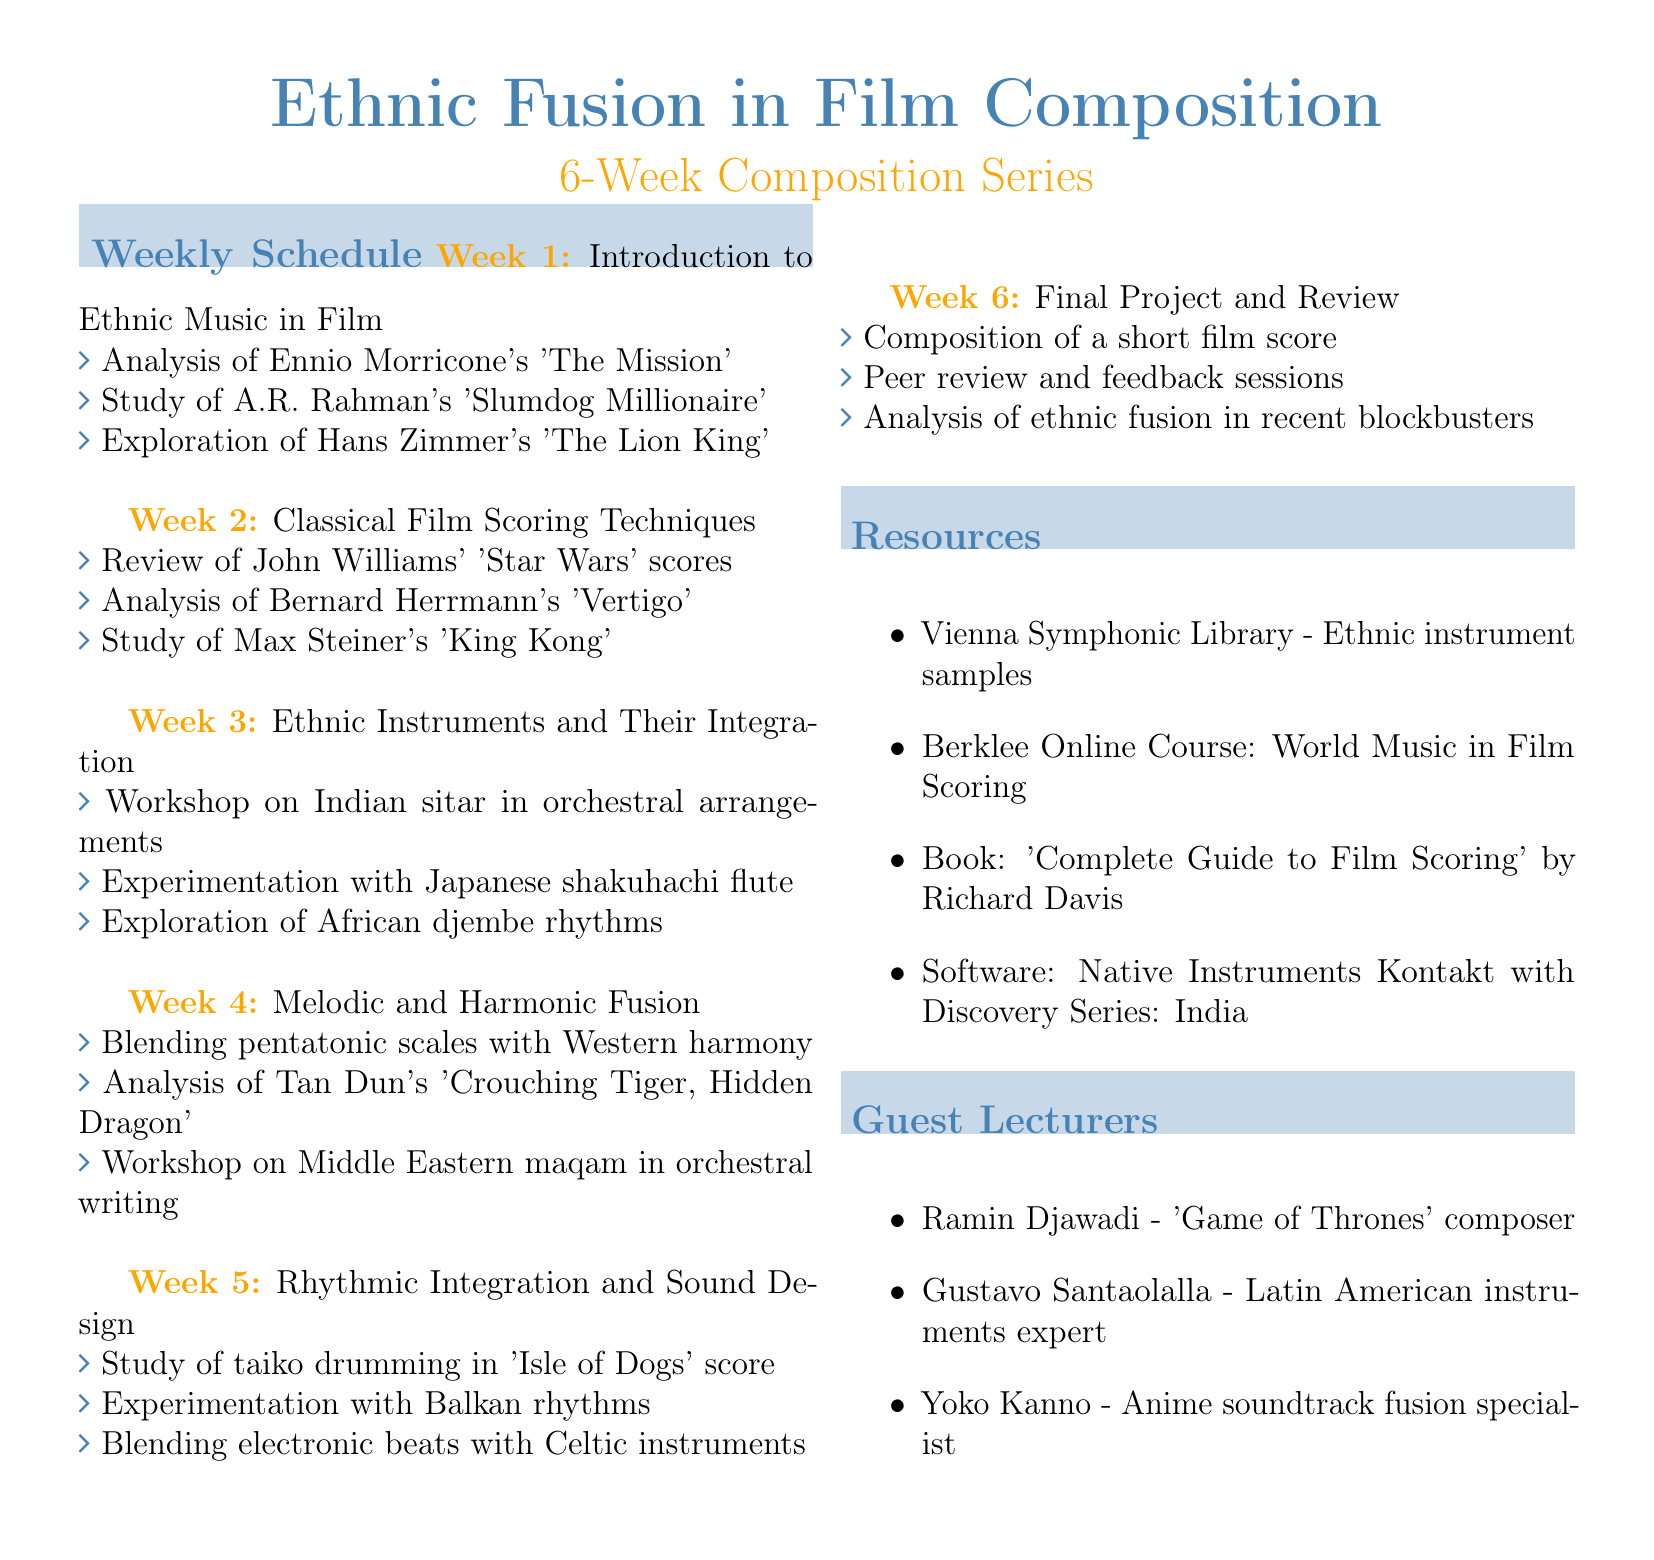What is the title of the session series? The title is the first line of the document.
Answer: Ethnic Fusion in Film Composition How long is the composition series? The duration is specified in the introduction section of the document.
Answer: 6 weeks Which week focuses on ethnic instruments? The week is identified in the Weekly Schedule section, under the third weekly topic.
Answer: Week 3 Who is a guest lecturer known for 'Game of Thrones'? The guest lecturer section lists several names, and this one is included among them.
Answer: Ramin Djawadi What type of activity occurs in week 4? This question pertains to the activities listed under the week 4 topic in the agenda.
Answer: Composition exercise How many weeks are allocated for the final project? The document specifies the sessions and their topics up to the final week.
Answer: 1 week What instrument is focused on during the workshop in week 3? The activities for this week detail the ethnic instruments to be integrated.
Answer: Indian sitar What are the two main areas explored in the series? The document outlines both ethnic music elements and classical scoring techniques throughout its sessions.
Answer: Ethnic music and classical film scoring Which composer was analyzed in week 2? Referring to the analysis activities listed under the topics for week 2.
Answer: Bernard Herrmann 